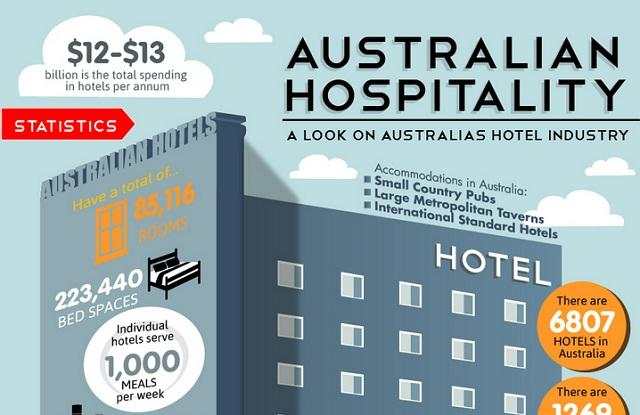Mention a couple of crucial points in this snapshot. The hotel serves approximately 1,000 meals per week. As of 2021, there are approximately 85,116 rooms in Australian hotels. 